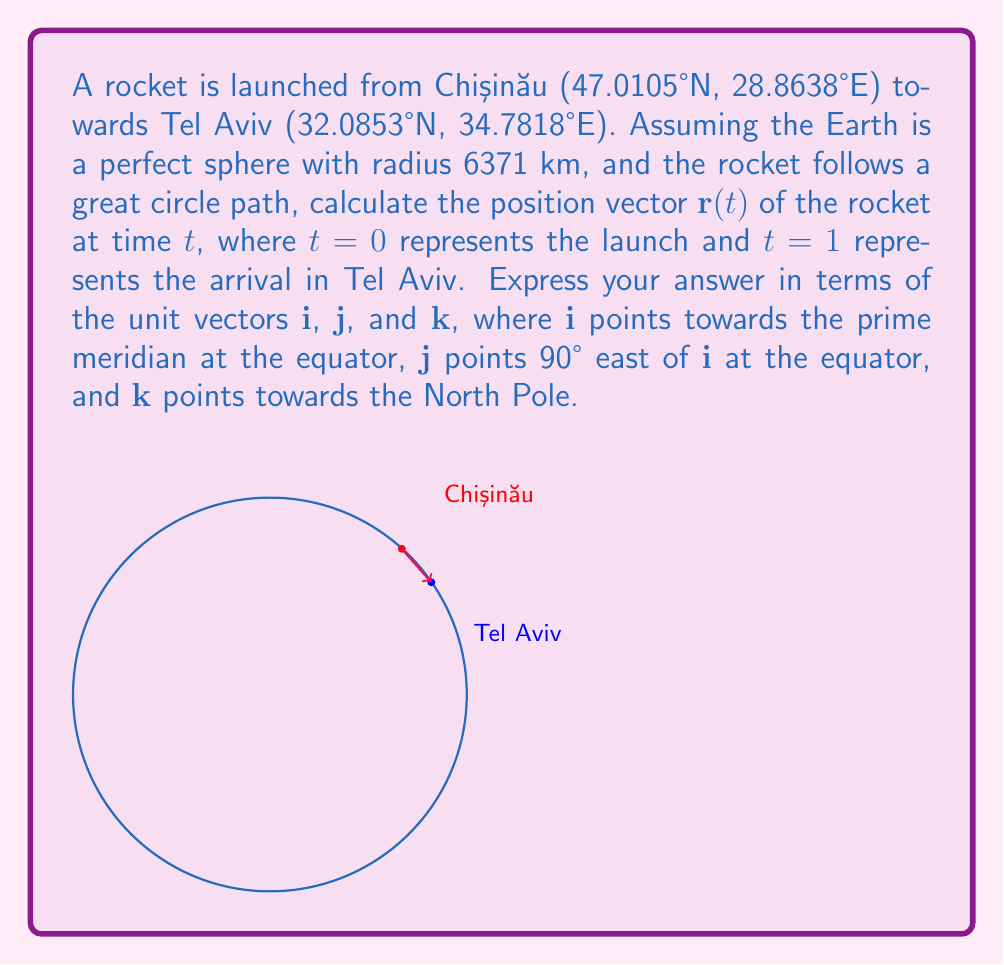Give your solution to this math problem. Let's approach this step-by-step:

1) First, we need to convert the latitude and longitude to 3D Cartesian coordinates. The formula is:
   $x = R \cos(\text{lat}) \cos(\text{lon})$
   $y = R \cos(\text{lat}) \sin(\text{lon})$
   $z = R \sin(\text{lat})$
   where R is the Earth's radius (6371 km).

2) For Chișinău:
   $\mathbf{r}_1 = (6371 \cos(47.0105°) \cos(28.8638°), 6371 \cos(47.0105°) \sin(28.8638°), 6371 \sin(47.0105°))$
   $\mathbf{r}_1 = (3473.62, 1896.97, 4651.52)$

3) For Tel Aviv:
   $\mathbf{r}_2 = (6371 \cos(32.0853°) \cos(34.7818°), 6371 \cos(32.0853°) \sin(34.7818°), 6371 \sin(32.0853°))$
   $\mathbf{r}_2 = (4331.32, 2987.47, 3375.87)$

4) The position vector $\mathbf{r}(t)$ can be expressed as a linear combination of $\mathbf{r}_1$ and $\mathbf{r}_2$:
   $\mathbf{r}(t) = (1-t)\mathbf{r}_1 + t\mathbf{r}_2$

5) Substituting the values:
   $\mathbf{r}(t) = (1-t)(3473.62\mathbf{i} + 1896.97\mathbf{j} + 4651.52\mathbf{k}) + t(4331.32\mathbf{i} + 2987.47\mathbf{j} + 3375.87\mathbf{k})$

6) Simplifying:
   $\mathbf{r}(t) = (3473.62 + 857.70t)\mathbf{i} + (1896.97 + 1090.50t)\mathbf{j} + (4651.52 - 1275.65t)\mathbf{k}$

This gives us the position vector of the rocket at any time $t$ between launch $(t=0)$ and arrival $(t=1)$.
Answer: $\mathbf{r}(t) = (3473.62 + 857.70t)\mathbf{i} + (1896.97 + 1090.50t)\mathbf{j} + (4651.52 - 1275.65t)\mathbf{k}$ 